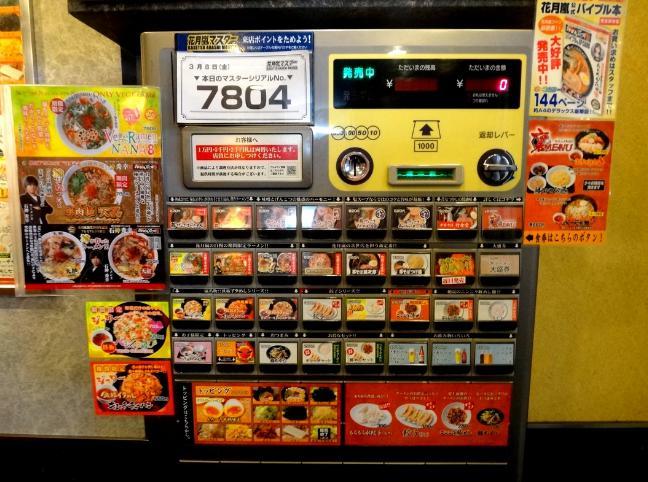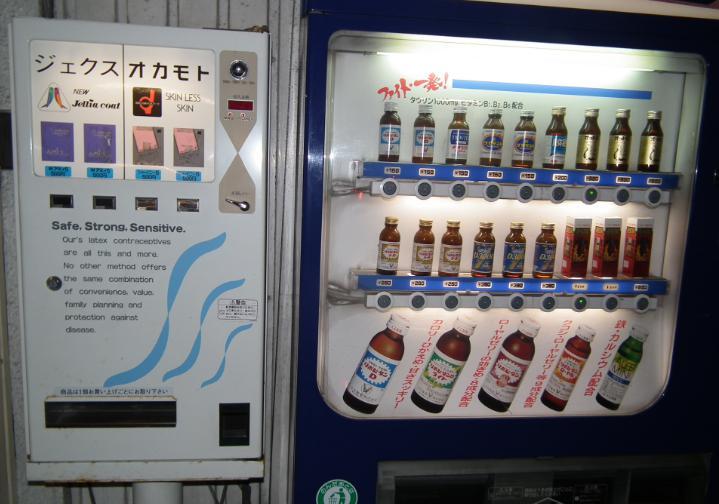The first image is the image on the left, the second image is the image on the right. For the images shown, is this caption "An image focuses on a blue vending machine that dispenses some bottled items." true? Answer yes or no. Yes. The first image is the image on the left, the second image is the image on the right. For the images displayed, is the sentence "Each image shows a row of at least three vending machines." factually correct? Answer yes or no. No. The first image is the image on the left, the second image is the image on the right. Considering the images on both sides, is "One of the machines sitting amongst the others is blue." valid? Answer yes or no. No. 